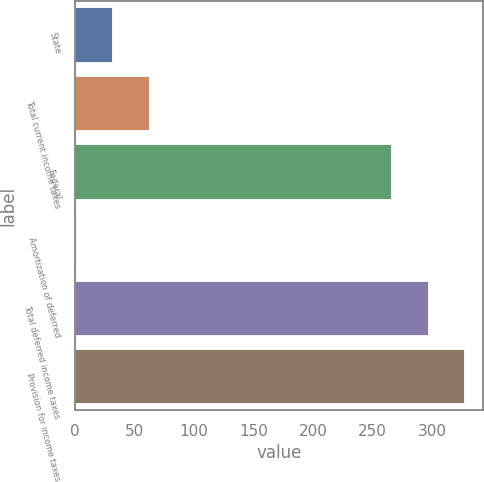Convert chart to OTSL. <chart><loc_0><loc_0><loc_500><loc_500><bar_chart><fcel>State<fcel>Total current income taxes<fcel>Federal<fcel>Amortization of deferred<fcel>Total deferred income taxes<fcel>Provision for income taxes<nl><fcel>31.5<fcel>62<fcel>265<fcel>1<fcel>296<fcel>326.5<nl></chart> 